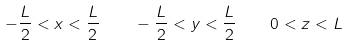Convert formula to latex. <formula><loc_0><loc_0><loc_500><loc_500>- \frac { L } { 2 } < x < \frac { L } { 2 } \quad - \frac { L } { 2 } < y < \frac { L } { 2 } \quad 0 < z < L</formula> 